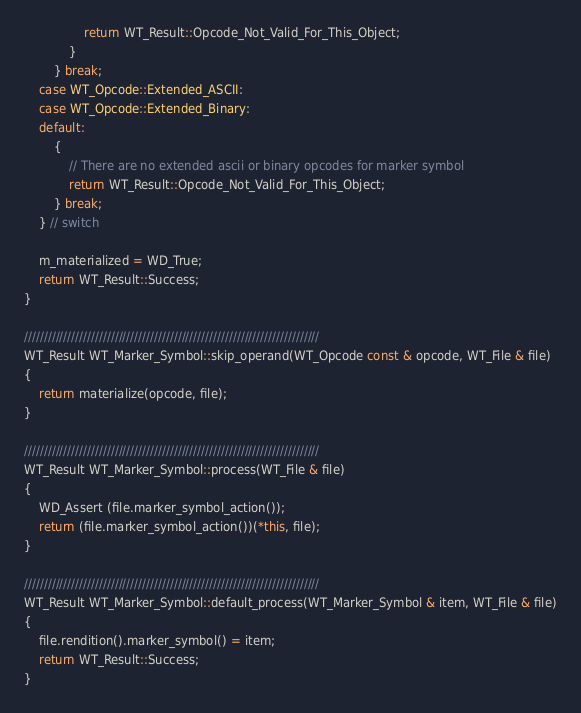<code> <loc_0><loc_0><loc_500><loc_500><_C++_>                return WT_Result::Opcode_Not_Valid_For_This_Object;
            }
        } break;
    case WT_Opcode::Extended_ASCII:
    case WT_Opcode::Extended_Binary:
    default:
        {
            // There are no extended ascii or binary opcodes for marker symbol
            return WT_Result::Opcode_Not_Valid_For_This_Object;
        } break;
    } // switch

    m_materialized = WD_True;
    return WT_Result::Success;
}

///////////////////////////////////////////////////////////////////////////
WT_Result WT_Marker_Symbol::skip_operand(WT_Opcode const & opcode, WT_File & file)
{
    return materialize(opcode, file);
}

///////////////////////////////////////////////////////////////////////////
WT_Result WT_Marker_Symbol::process(WT_File & file)
{
    WD_Assert (file.marker_symbol_action());
    return (file.marker_symbol_action())(*this, file);
}

///////////////////////////////////////////////////////////////////////////
WT_Result WT_Marker_Symbol::default_process(WT_Marker_Symbol & item, WT_File & file)
{
    file.rendition().marker_symbol() = item;
    return WT_Result::Success;
}
</code> 